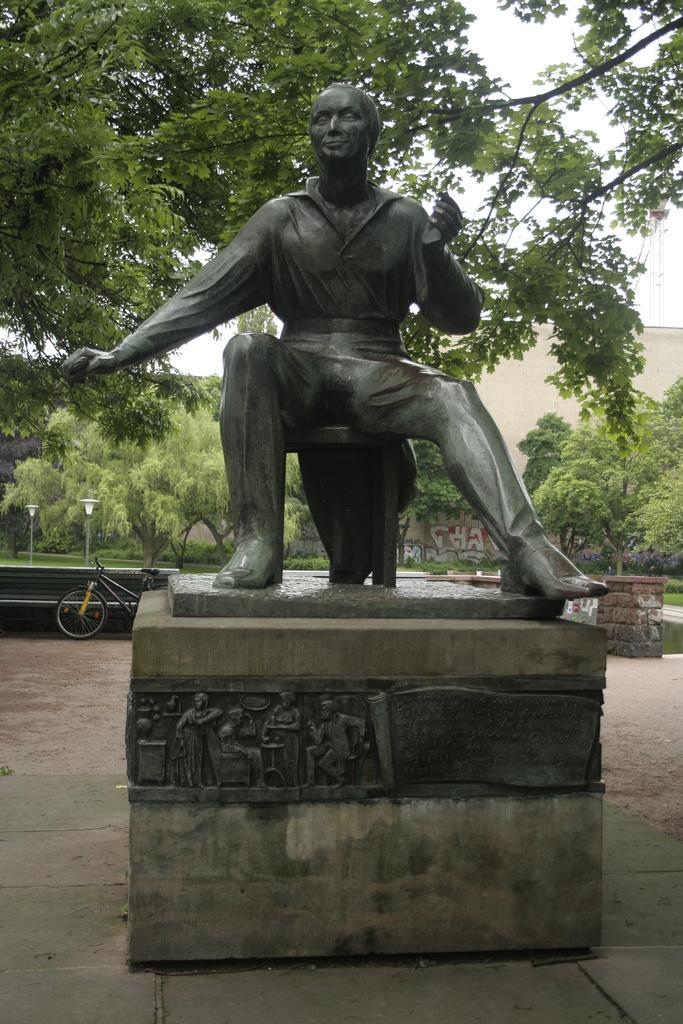How would you summarize this image in a sentence or two? In the center of the image there is a statue. In the background of the image there are trees. There is a building. There is a bicycle. At the bottom of the image there is floor. 